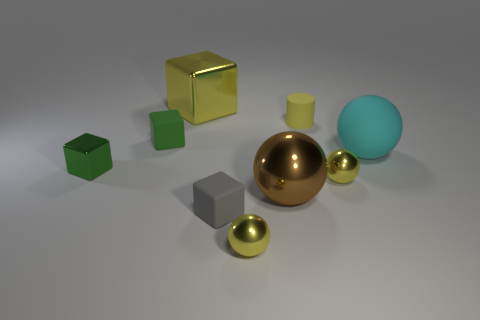There is a small thing that is behind the tiny green cube that is on the right side of the green shiny object that is left of the tiny gray matte object; what is it made of? The small thing behind the tiny green cube, to the right of the green shiny object and to the left of the gray matte object, appears to be a smaller golden sphere. Based on the image, the golden sphere, like its larger counterpart, is likely made of a metallic material, potentially mimicking the appearance of polished brass or gold. 